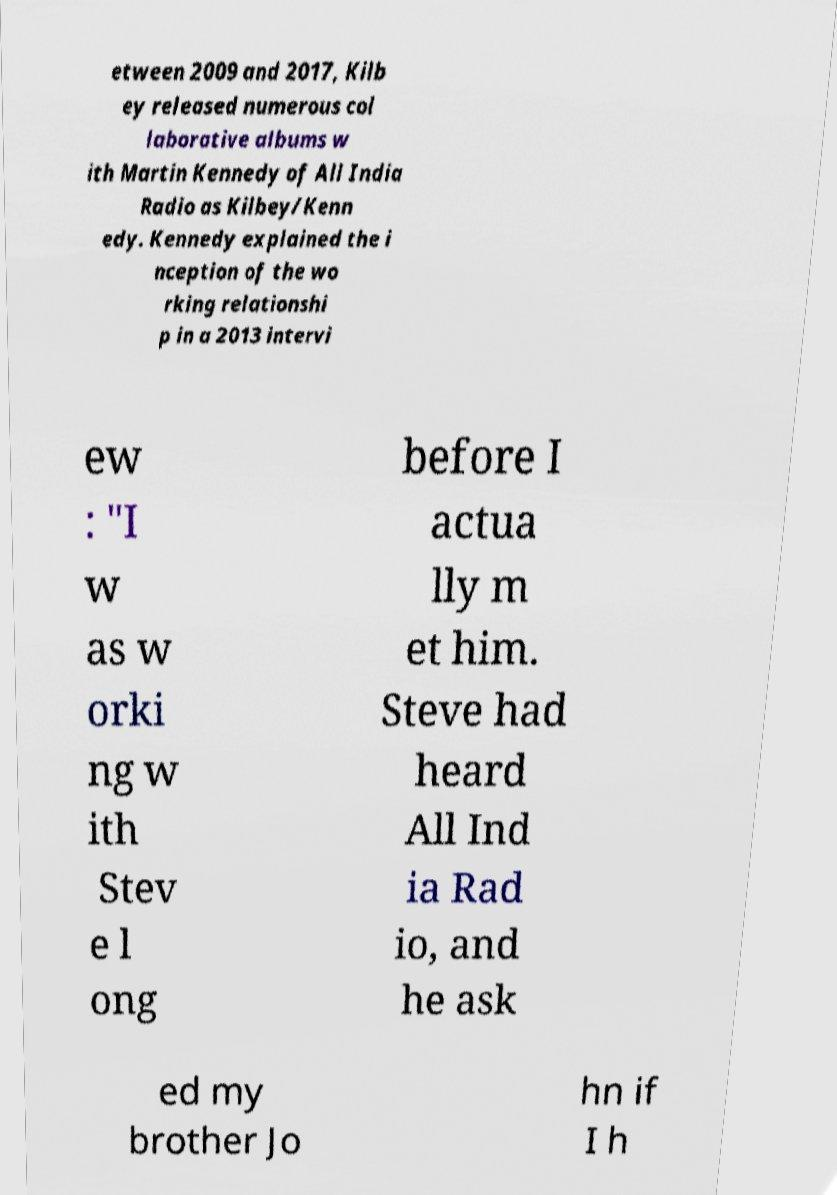I need the written content from this picture converted into text. Can you do that? etween 2009 and 2017, Kilb ey released numerous col laborative albums w ith Martin Kennedy of All India Radio as Kilbey/Kenn edy. Kennedy explained the i nception of the wo rking relationshi p in a 2013 intervi ew : "I w as w orki ng w ith Stev e l ong before I actua lly m et him. Steve had heard All Ind ia Rad io, and he ask ed my brother Jo hn if I h 